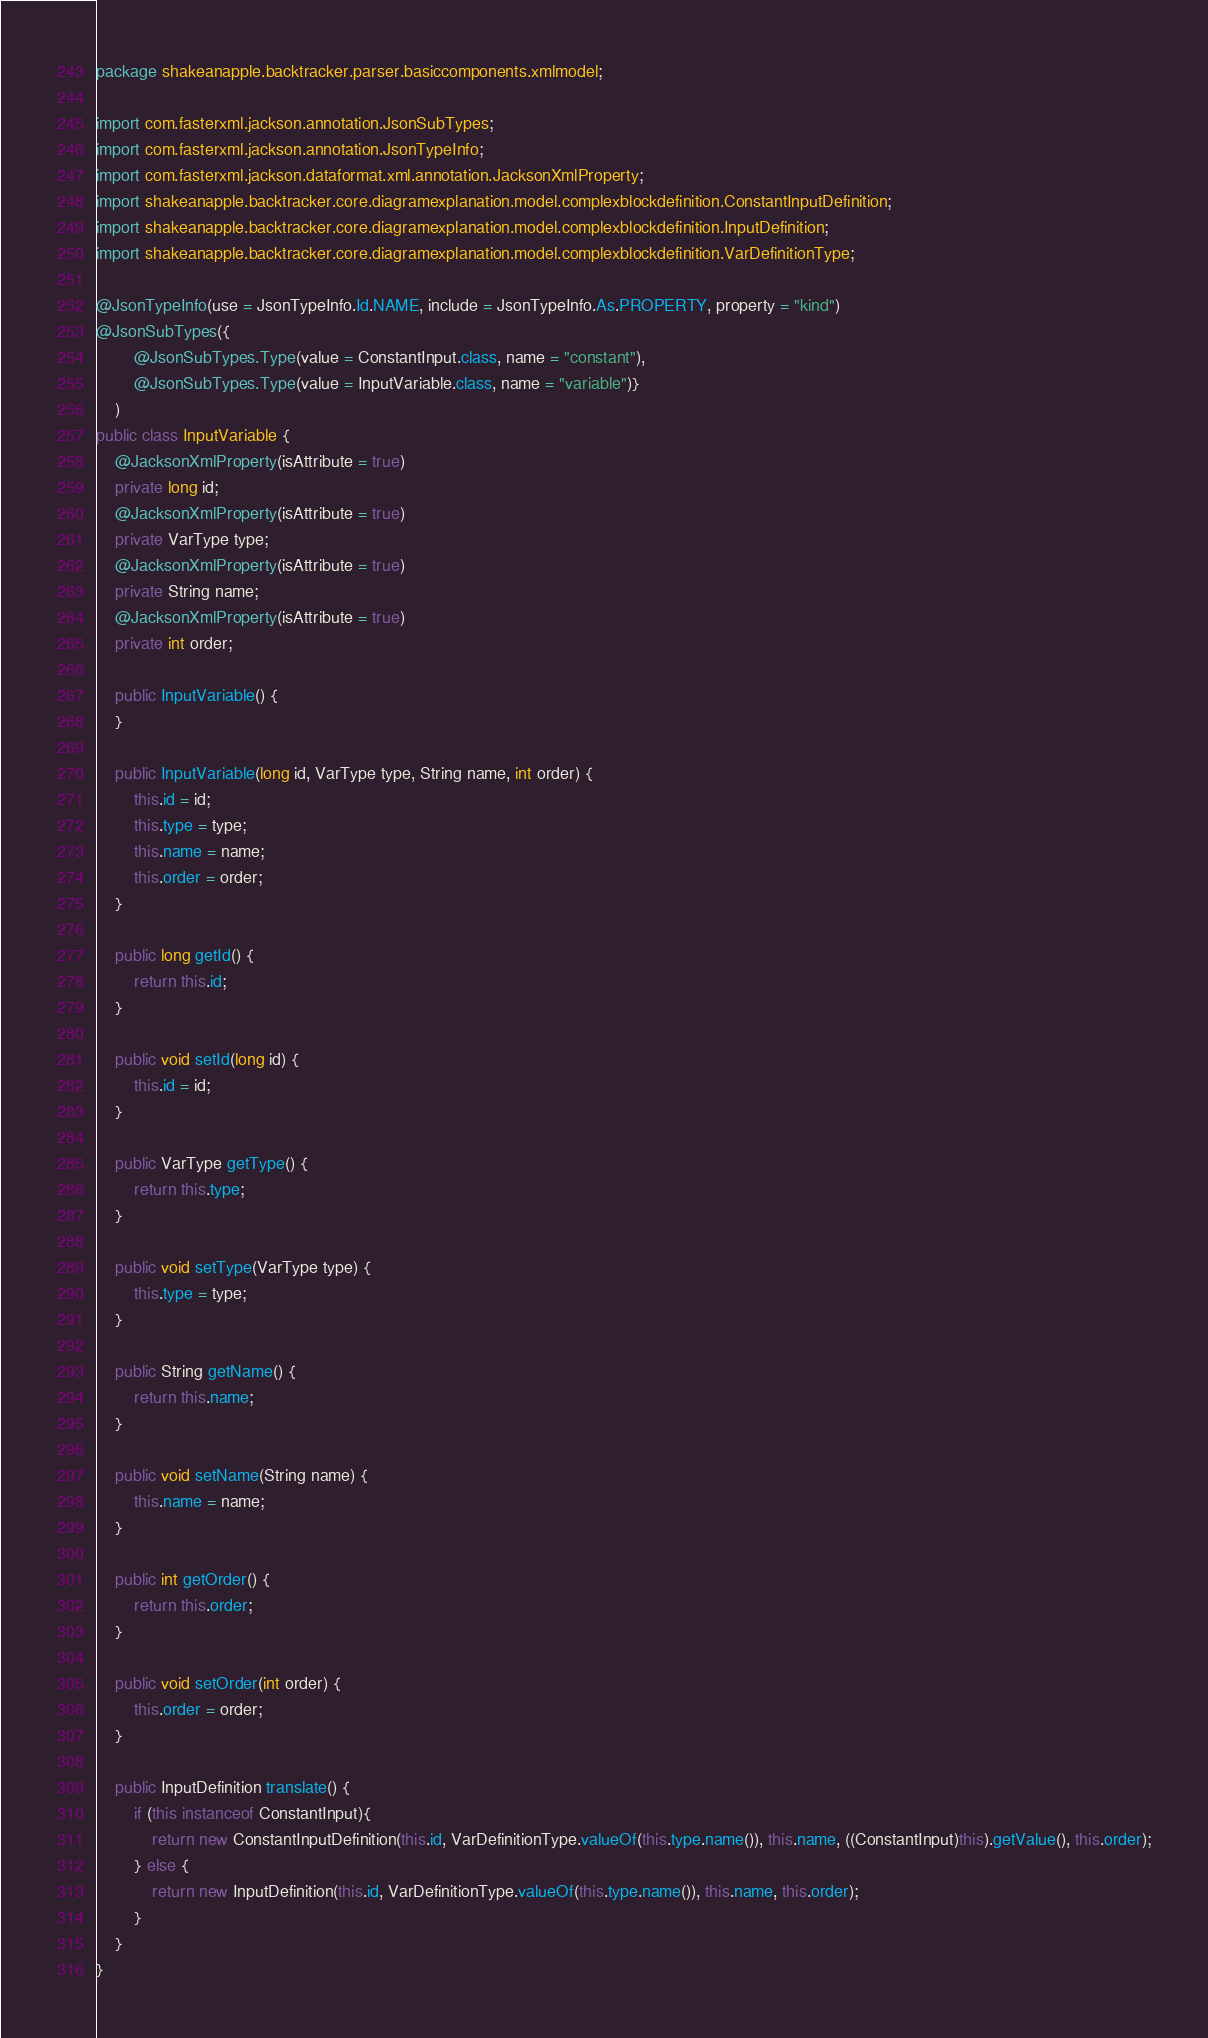Convert code to text. <code><loc_0><loc_0><loc_500><loc_500><_Java_>package shakeanapple.backtracker.parser.basiccomponents.xmlmodel;

import com.fasterxml.jackson.annotation.JsonSubTypes;
import com.fasterxml.jackson.annotation.JsonTypeInfo;
import com.fasterxml.jackson.dataformat.xml.annotation.JacksonXmlProperty;
import shakeanapple.backtracker.core.diagramexplanation.model.complexblockdefinition.ConstantInputDefinition;
import shakeanapple.backtracker.core.diagramexplanation.model.complexblockdefinition.InputDefinition;
import shakeanapple.backtracker.core.diagramexplanation.model.complexblockdefinition.VarDefinitionType;

@JsonTypeInfo(use = JsonTypeInfo.Id.NAME, include = JsonTypeInfo.As.PROPERTY, property = "kind")
@JsonSubTypes({
        @JsonSubTypes.Type(value = ConstantInput.class, name = "constant"),
        @JsonSubTypes.Type(value = InputVariable.class, name = "variable")}
    )
public class InputVariable {
    @JacksonXmlProperty(isAttribute = true)
    private long id;
    @JacksonXmlProperty(isAttribute = true)
    private VarType type;
    @JacksonXmlProperty(isAttribute = true)
    private String name;
    @JacksonXmlProperty(isAttribute = true)
    private int order;

    public InputVariable() {
    }

    public InputVariable(long id, VarType type, String name, int order) {
        this.id = id;
        this.type = type;
        this.name = name;
        this.order = order;
    }

    public long getId() {
        return this.id;
    }

    public void setId(long id) {
        this.id = id;
    }

    public VarType getType() {
        return this.type;
    }

    public void setType(VarType type) {
        this.type = type;
    }

    public String getName() {
        return this.name;
    }

    public void setName(String name) {
        this.name = name;
    }

    public int getOrder() {
        return this.order;
    }

    public void setOrder(int order) {
        this.order = order;
    }

    public InputDefinition translate() {
        if (this instanceof ConstantInput){
            return new ConstantInputDefinition(this.id, VarDefinitionType.valueOf(this.type.name()), this.name, ((ConstantInput)this).getValue(), this.order);
        } else {
            return new InputDefinition(this.id, VarDefinitionType.valueOf(this.type.name()), this.name, this.order);
        }
    }
}
</code> 